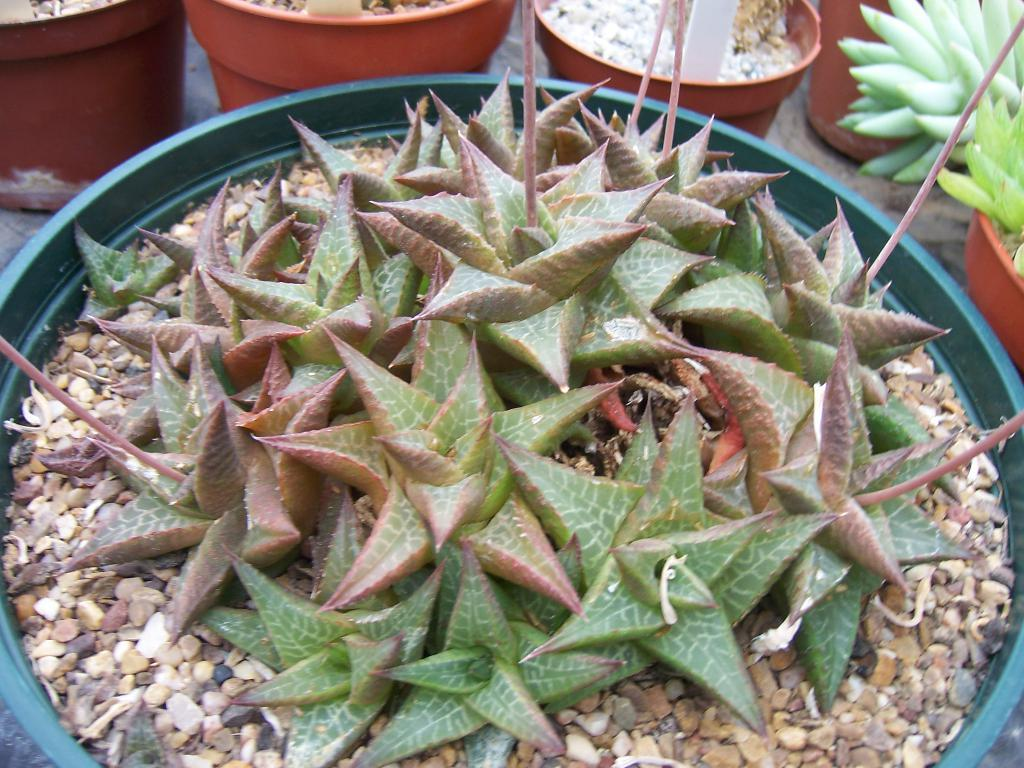What type of plants are visible in the image? There are houseplants in the image. Can you describe the setting where the houseplants are located? The image does not provide enough information to determine the setting where the houseplants are located. How many houseplants can be seen in the image? The image does not provide enough information to determine the exact number of houseplants visible. What type of soap is being used by the doctor in the image? There is no doctor or soap present in the image; it only features houseplants. 